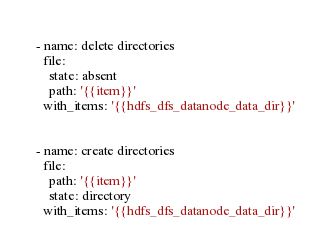<code> <loc_0><loc_0><loc_500><loc_500><_YAML_>- name: delete directories
  file:
    state: absent
    path: '{{item}}'
  with_items: '{{hdfs_dfs_datanode_data_dir}}'


- name: create directories
  file:
    path: '{{item}}'
    state: directory
  with_items: '{{hdfs_dfs_datanode_data_dir}}'
</code> 